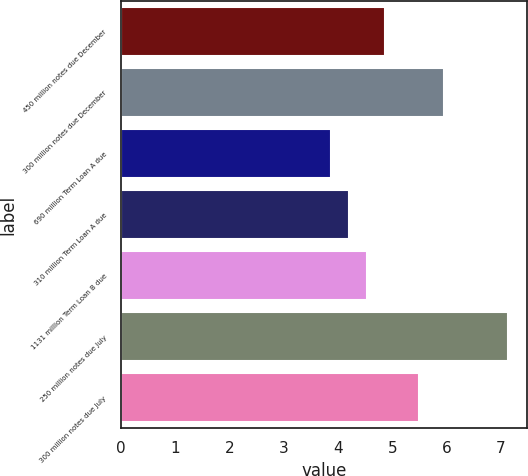Convert chart. <chart><loc_0><loc_0><loc_500><loc_500><bar_chart><fcel>450 million notes due December<fcel>300 million notes due December<fcel>690 million Term Loan A due<fcel>310 million Term Loan A due<fcel>1131 million Term Loan B due<fcel>250 million notes due July<fcel>300 million notes due July<nl><fcel>4.87<fcel>5.95<fcel>3.88<fcel>4.21<fcel>4.54<fcel>7.13<fcel>5.5<nl></chart> 